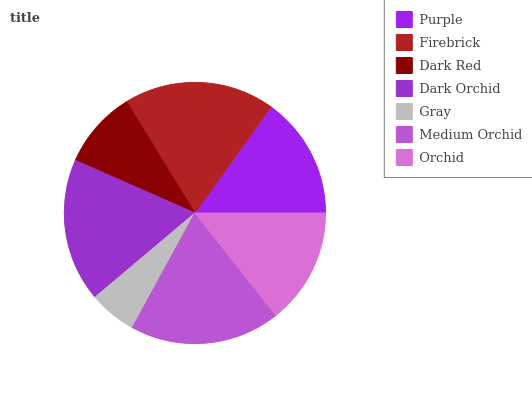Is Gray the minimum?
Answer yes or no. Yes. Is Firebrick the maximum?
Answer yes or no. Yes. Is Dark Red the minimum?
Answer yes or no. No. Is Dark Red the maximum?
Answer yes or no. No. Is Firebrick greater than Dark Red?
Answer yes or no. Yes. Is Dark Red less than Firebrick?
Answer yes or no. Yes. Is Dark Red greater than Firebrick?
Answer yes or no. No. Is Firebrick less than Dark Red?
Answer yes or no. No. Is Purple the high median?
Answer yes or no. Yes. Is Purple the low median?
Answer yes or no. Yes. Is Medium Orchid the high median?
Answer yes or no. No. Is Orchid the low median?
Answer yes or no. No. 